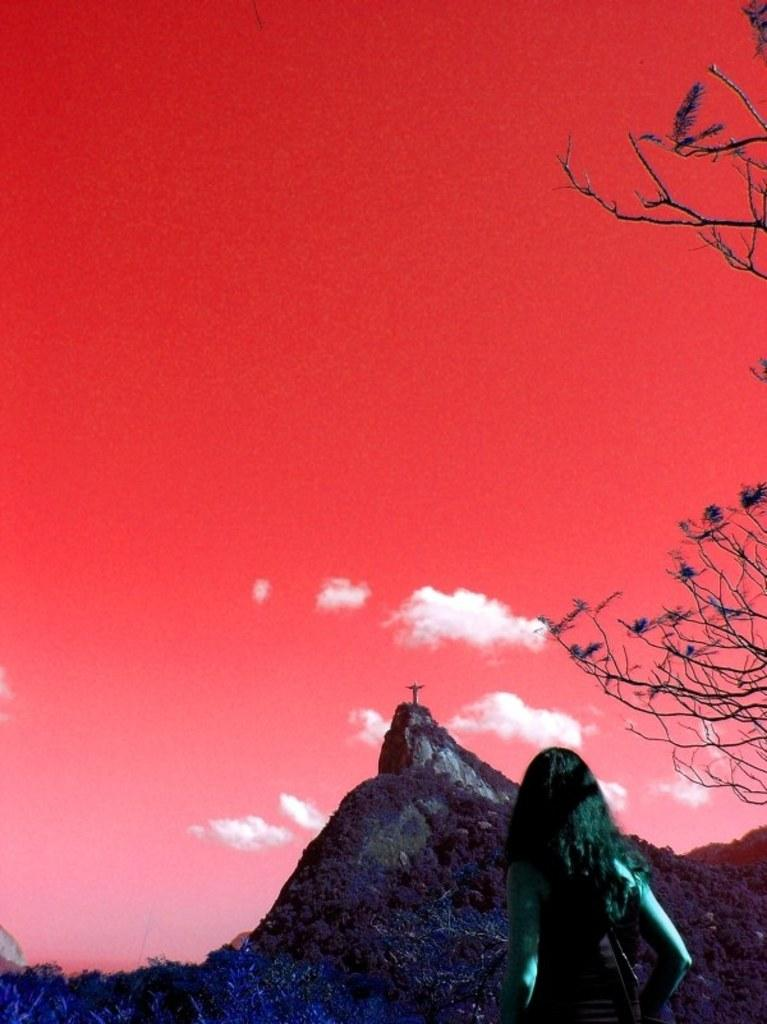What type of artwork is depicted in the image? The image is a painting. Can you describe the woman's location in the painting? There is a woman standing near a mountain in the painting. What type of vegetation is on the right side of the image? There are trees on the right side of the image. What color is the sky in the background of the painting? The sky is red in the background of the image. How long does it take for the woman to walk from the mountain to the dock in the image? There is no dock present in the image, so it is not possible to determine how long it would take for the woman to walk from the mountain to the dock. 